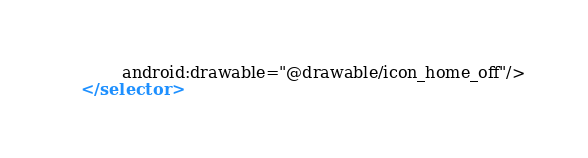<code> <loc_0><loc_0><loc_500><loc_500><_XML_>        android:drawable="@drawable/icon_home_off"/>
</selector></code> 